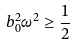Convert formula to latex. <formula><loc_0><loc_0><loc_500><loc_500>b _ { 0 } ^ { 2 } { \omega } ^ { 2 } \geq \frac { 1 } { 2 }</formula> 